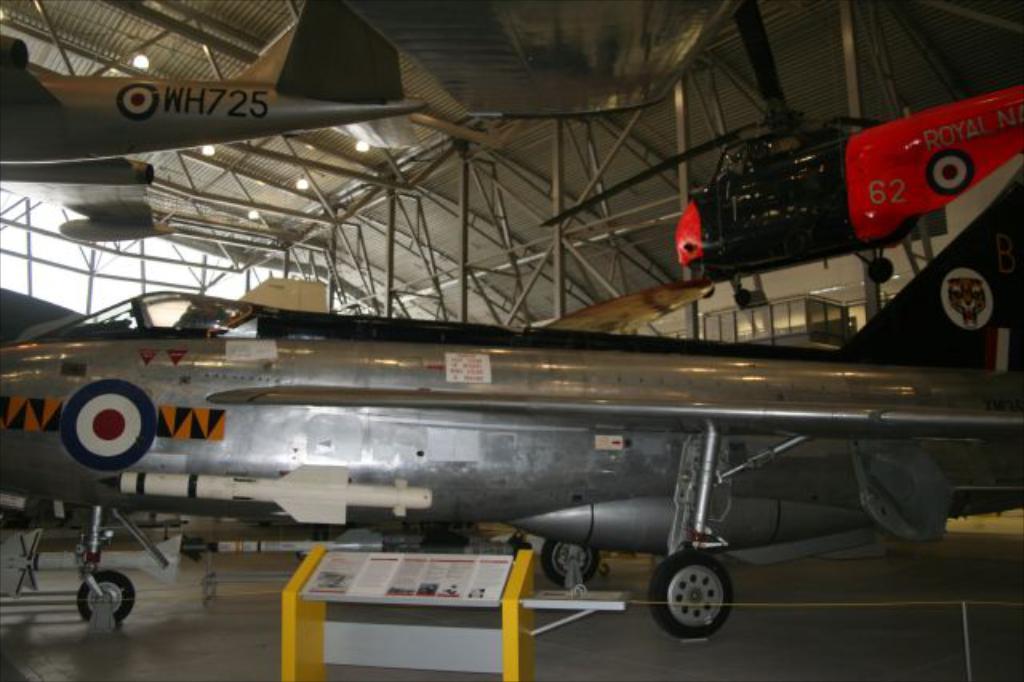What is the number of the plane hanging from the ceiling?
Offer a terse response. Wh725. What number is on the red helicopter?
Your answer should be very brief. 62. 